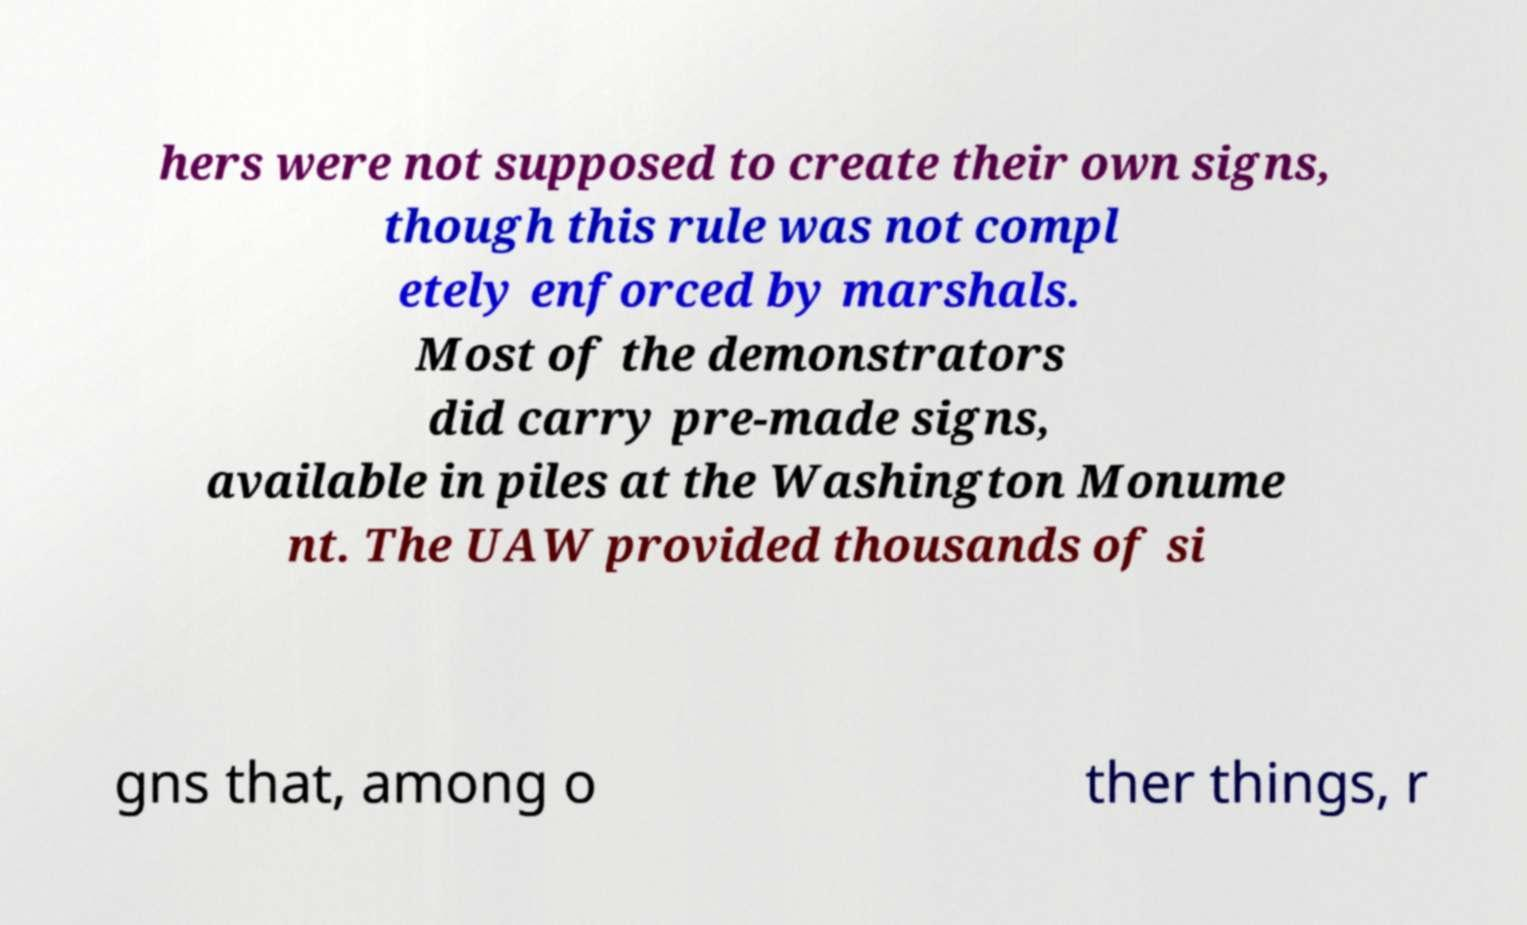There's text embedded in this image that I need extracted. Can you transcribe it verbatim? hers were not supposed to create their own signs, though this rule was not compl etely enforced by marshals. Most of the demonstrators did carry pre-made signs, available in piles at the Washington Monume nt. The UAW provided thousands of si gns that, among o ther things, r 